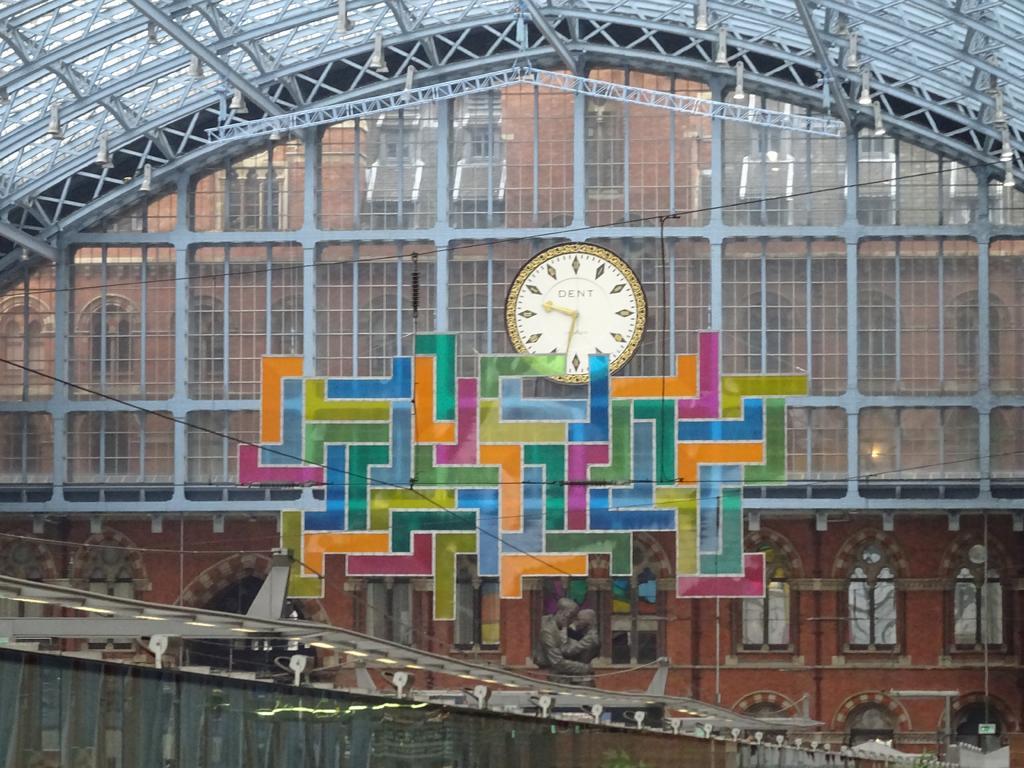Please provide a concise description of this image. In this picture we can see a building, windows, clock, roof, rods, statue, bridge, shed, sign boards, poles, wall. 